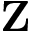<formula> <loc_0><loc_0><loc_500><loc_500>Z</formula> 